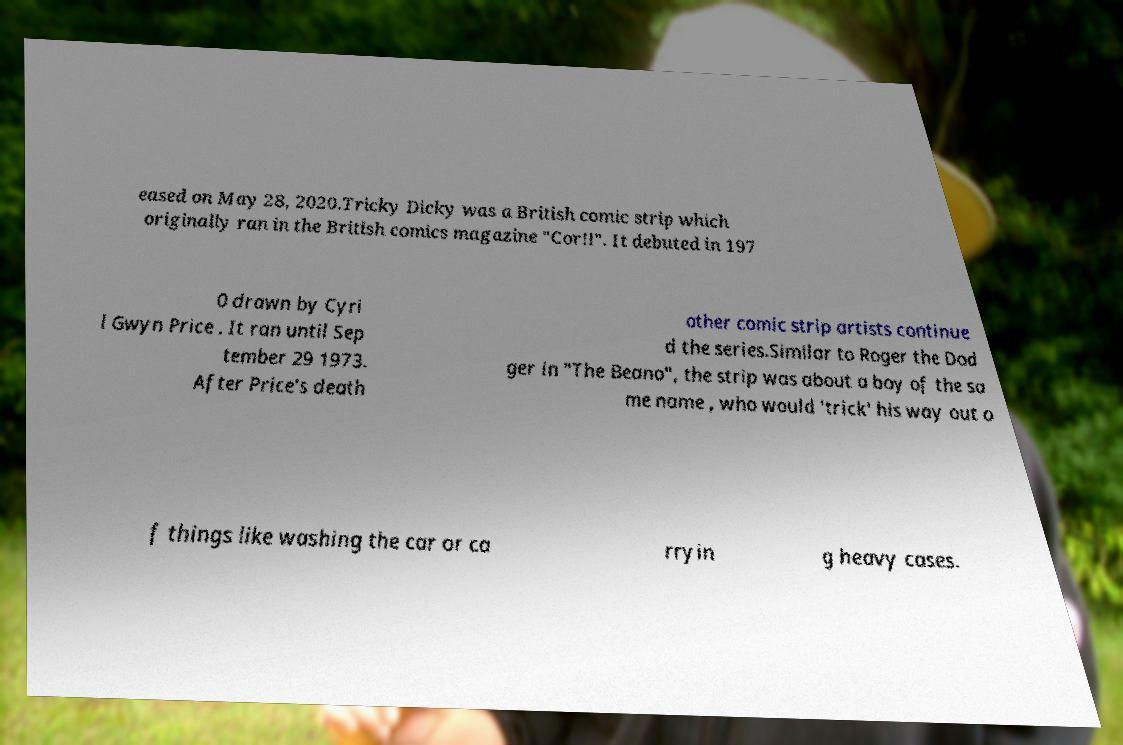Can you read and provide the text displayed in the image?This photo seems to have some interesting text. Can you extract and type it out for me? eased on May 28, 2020.Tricky Dicky was a British comic strip which originally ran in the British comics magazine "Cor!!". It debuted in 197 0 drawn by Cyri l Gwyn Price . It ran until Sep tember 29 1973. After Price's death other comic strip artists continue d the series.Similar to Roger the Dod ger in "The Beano", the strip was about a boy of the sa me name , who would 'trick' his way out o f things like washing the car or ca rryin g heavy cases. 